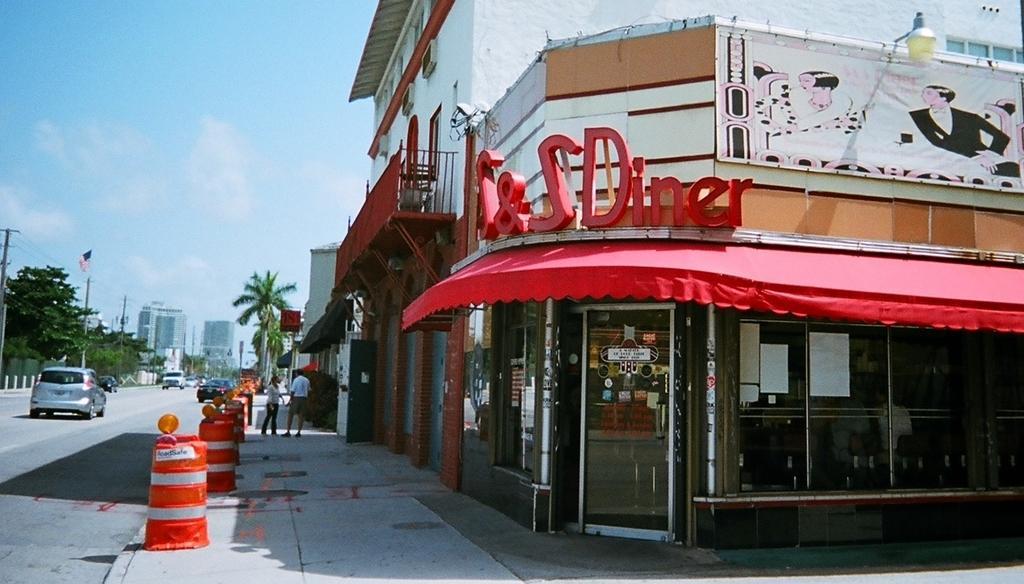How would you summarize this image in a sentence or two? In this image we can see a shop. Left side of the image road is there, on road cars are moving. Middle of the image pavement is there and two persons are standing. To the corner of the pavement orange and white color barrels are there. Background of the image buildings and trees are present. And we can see electric poles and wires. The sky is in blue color. 